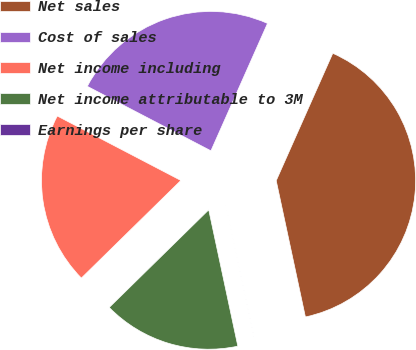Convert chart. <chart><loc_0><loc_0><loc_500><loc_500><pie_chart><fcel>Net sales<fcel>Cost of sales<fcel>Net income including<fcel>Net income attributable to 3M<fcel>Earnings per share<nl><fcel>39.99%<fcel>24.0%<fcel>20.0%<fcel>16.0%<fcel>0.01%<nl></chart> 